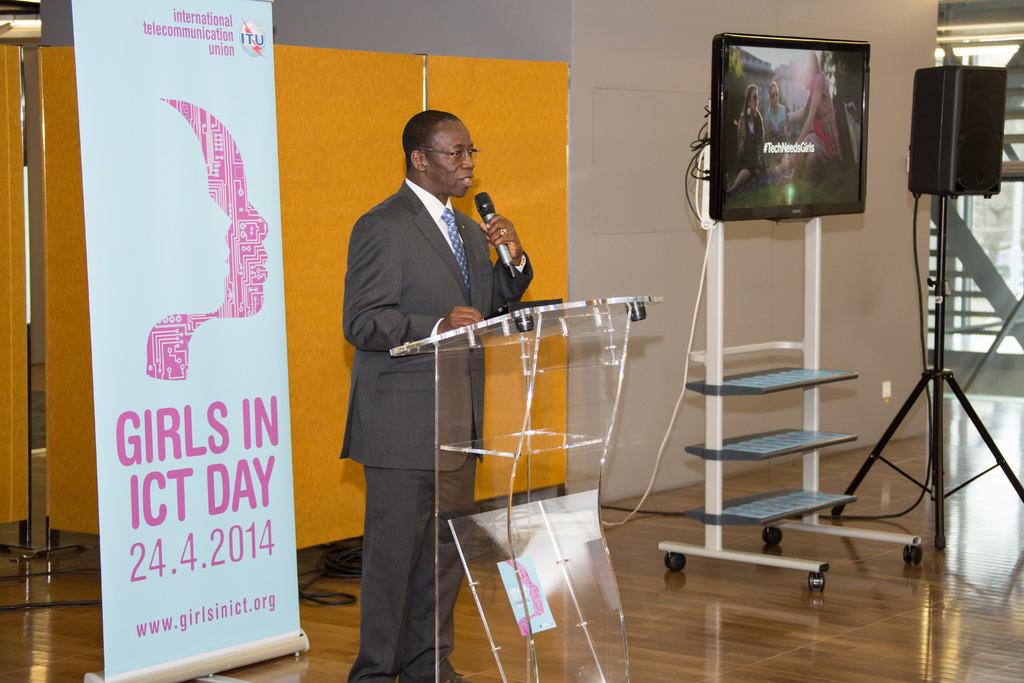<image>
Present a compact description of the photo's key features. A man speaks at an event called Girls In ICT Day. 